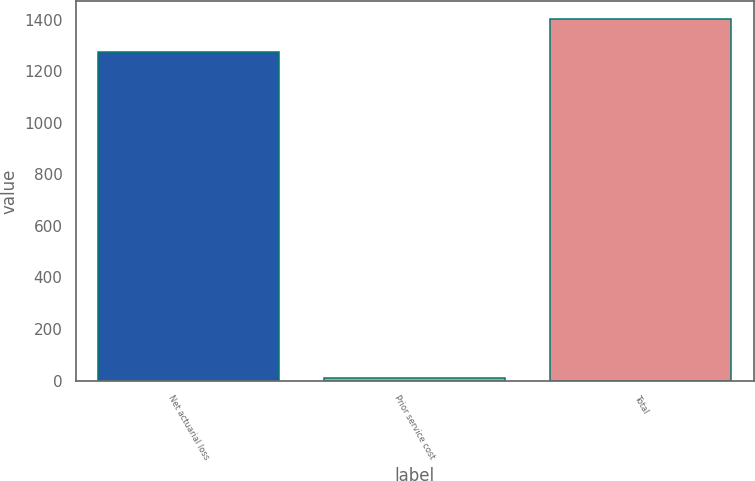<chart> <loc_0><loc_0><loc_500><loc_500><bar_chart><fcel>Net actuarial loss<fcel>Prior service cost<fcel>Total<nl><fcel>1273.6<fcel>8.5<fcel>1400.96<nl></chart> 